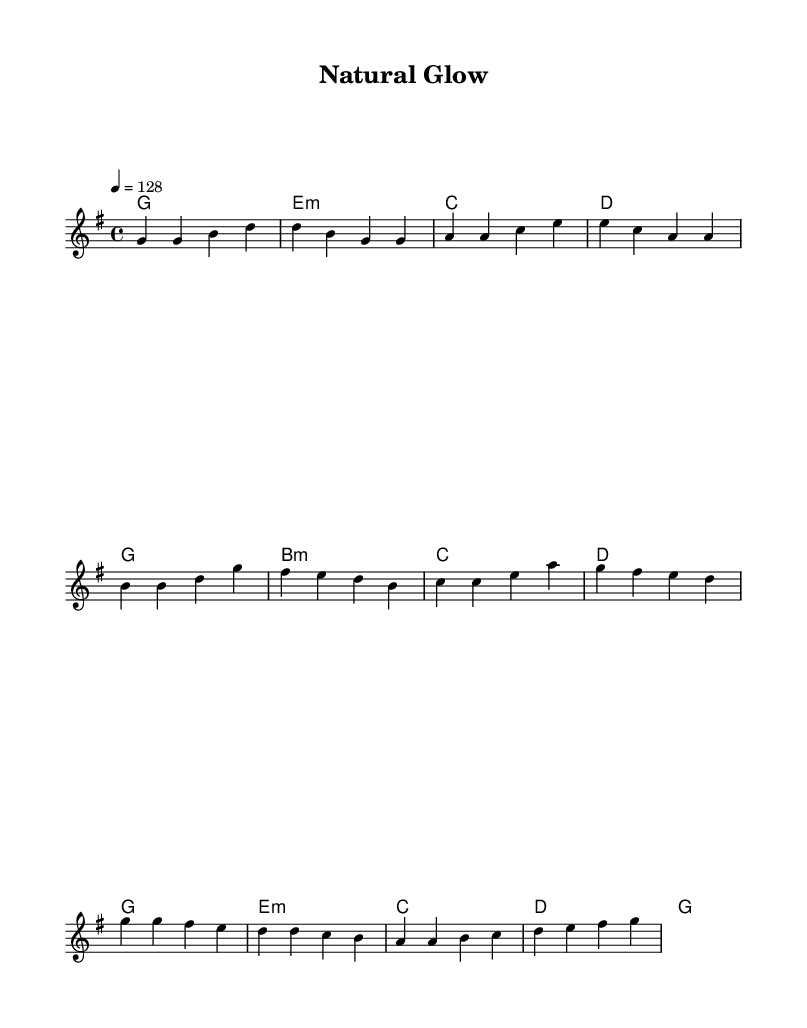What is the key signature of this music? The key signature is G major, which has one sharp (F#). This is determined by looking at the key signature indicated at the beginning of the staff, which shows the F# note.
Answer: G major What is the time signature of this music? The time signature is 4/4, indicated at the beginning of the score. It means there are four beats in a measure and the quarter note gets one beat.
Answer: 4/4 What is the tempo marking of this music? The tempo marking is 128 beats per minute, which is indicated by "4 = 128" under the tempo notation. This tells performers how fast to play the piece.
Answer: 128 How many measures are in the verse section? The verse consists of 4 measures, as indicated by the sequence of notes and rests within that section. Each group of notes separated by the vertical lines represents one measure.
Answer: 4 Which chords are used in the pre-chorus section? The chords used in the pre-chorus are G, B minor, C, and D. Each chord is shown above the corresponding melody notes and identifies harmonic support for that section.
Answer: G, B minor, C, D What is the chorus melody's highest note? The highest note in the chorus melody is G, which appears at the beginning of the chorus melody line. It is necessary to analyze the melody notes to find the peak.
Answer: G What theme does this K-Pop song's lyrics likely revolve around? The theme likely revolves around natural beauty and self-care routines, as implied by the title "Natural Glow" and the upbeat style typical of K-Pop songs that emphasize positivity and self-empowerment.
Answer: Natural beauty and self-care 